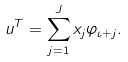<formula> <loc_0><loc_0><loc_500><loc_500>u ^ { T } = \sum _ { j = 1 } ^ { J } x _ { j } \varphi _ { \iota + j } .</formula> 